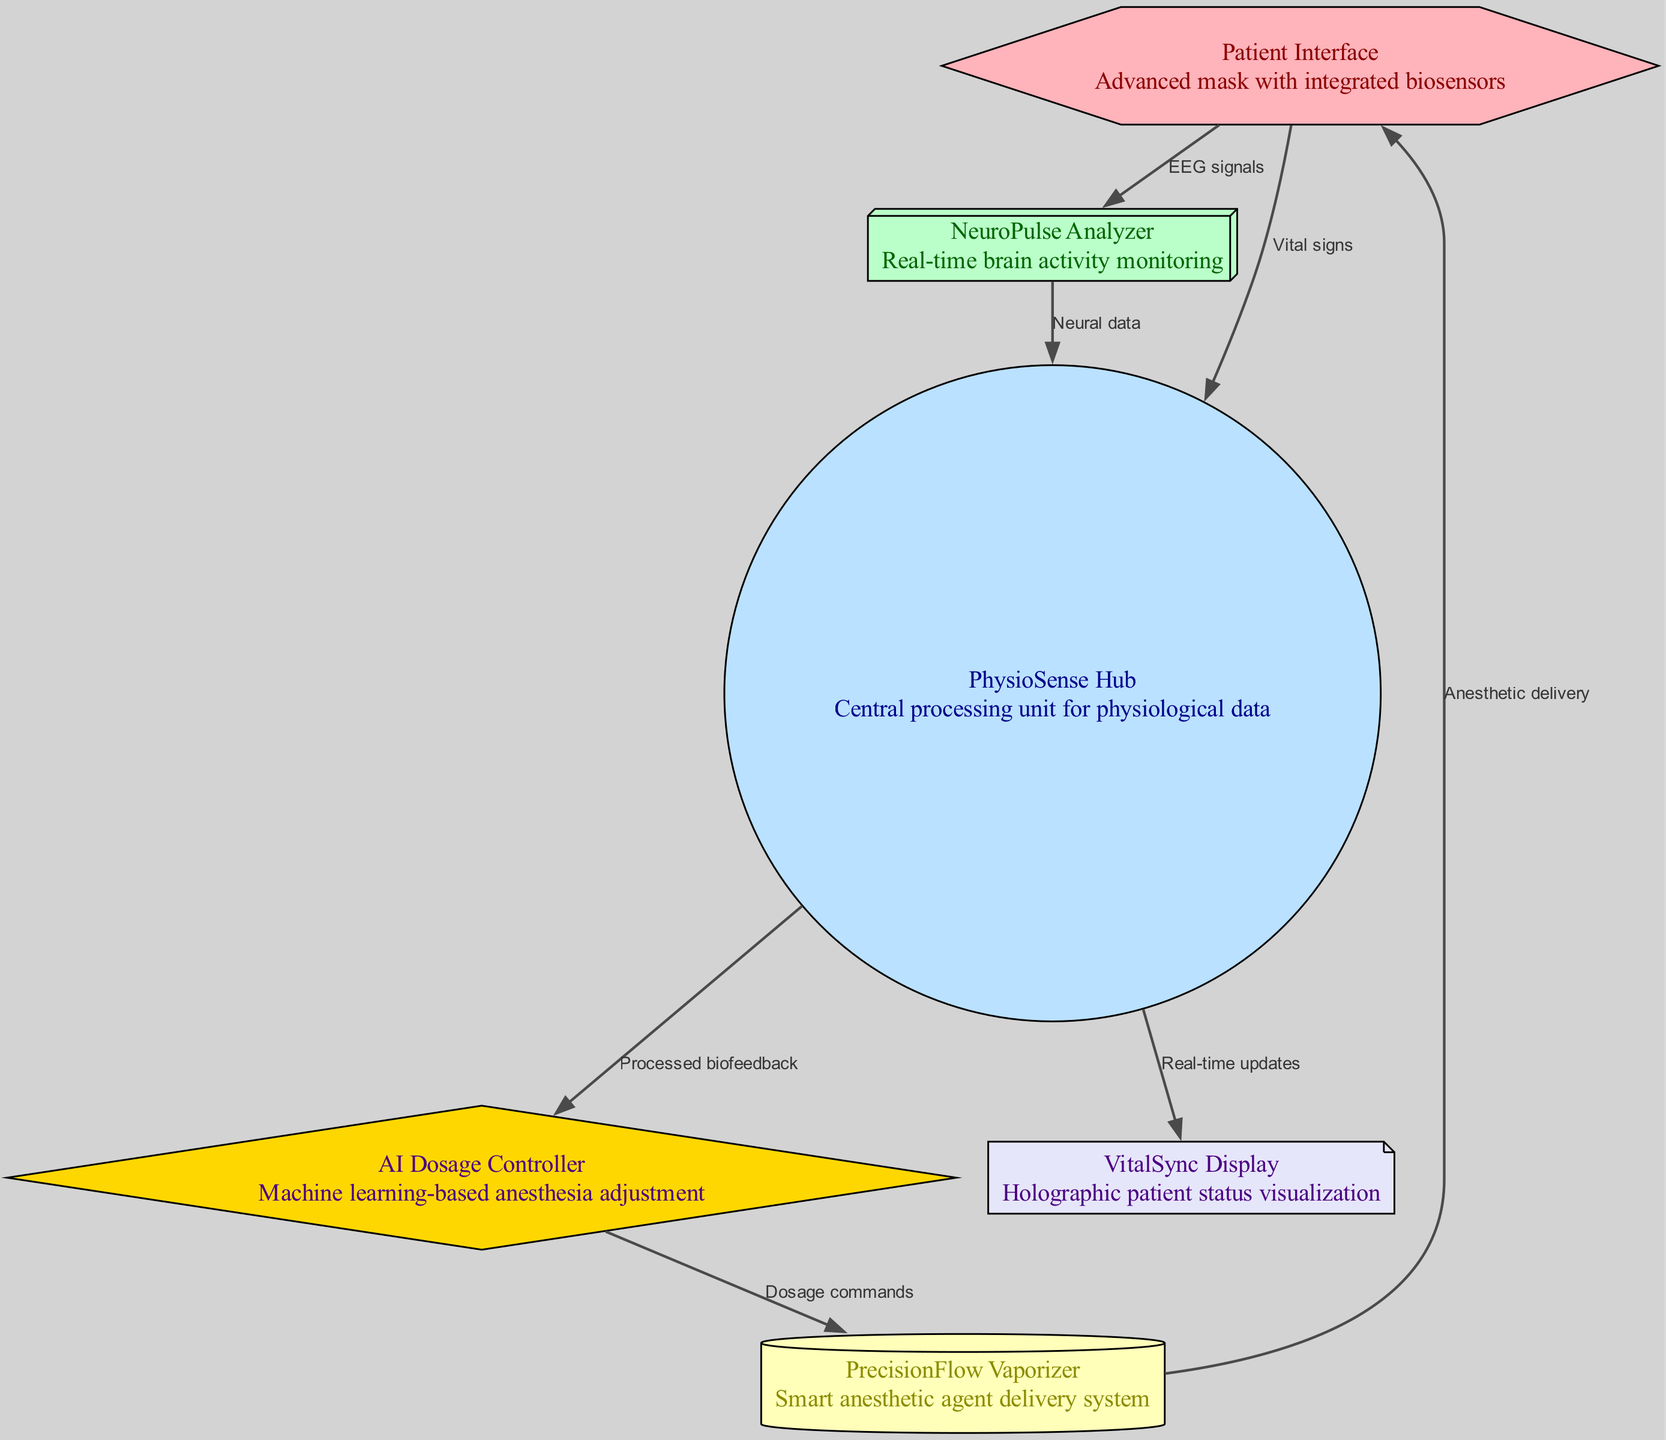What is the total number of nodes in the diagram? The diagram lists six distinct nodes, each representing a component of the anesthesia delivery system. Counting them gives a total of six nodes.
Answer: 6 What is the role of the PhysioSense Hub? The PhysioSense Hub serves as the central processing unit for physiological data, integrating inputs from various sources, including the Patient Interface and NeuroPulse Analyzer.
Answer: Central processing unit for physiological data How many edges connect the Patient Interface to other nodes? The Patient Interface connects to two other nodes: one to the NeuroPulse Analyzer for EEG signals and another to the PhysioSense Hub for vital signs. Adding these edges together gives a total of two connections.
Answer: 2 What type of data is sent from the NeuroPulse Analyzer to the PhysioSense Hub? The diagram specifies that the NeuroPulse Analyzer sends neural data to the PhysioSense Hub, which is essential for analyzing brain activity in conjunction with other physiological signals.
Answer: Neural data Which node receives dosage commands from the AI Dosage Controller? The edge from the AI Dosage Controller points to the PrecisionFlow Vaporizer, indicating that this node is responsible for receiving commands related to the administration of anesthetic dosages.
Answer: PrecisionFlow Vaporizer How does the PrecisionFlow Vaporizer deliver anesthetics to the Patient Interface? The diagram shows an edge leading from the PrecisionFlow Vaporizer back to the Patient Interface, indicating that the vaporizer delivers the anesthetic agents directly to the patient via the advanced mask.
Answer: Anesthetic delivery What type of visualization is provided by the VitalSync Display? The VitalSync Display is described as offering holographic patient status visualization, which allows for a dynamic and informative view of the patient's physiological data in real-time.
Answer: Holographic patient status visualization How does the AI Dosage Controller process input data? The AI Dosage Controller receives processed biofeedback data from the PhysioSense Hub, utilizing this information to dynamically adjust the anesthesia dosage based on real-time patient needs.
Answer: Machine learning-based anesthesia adjustment 